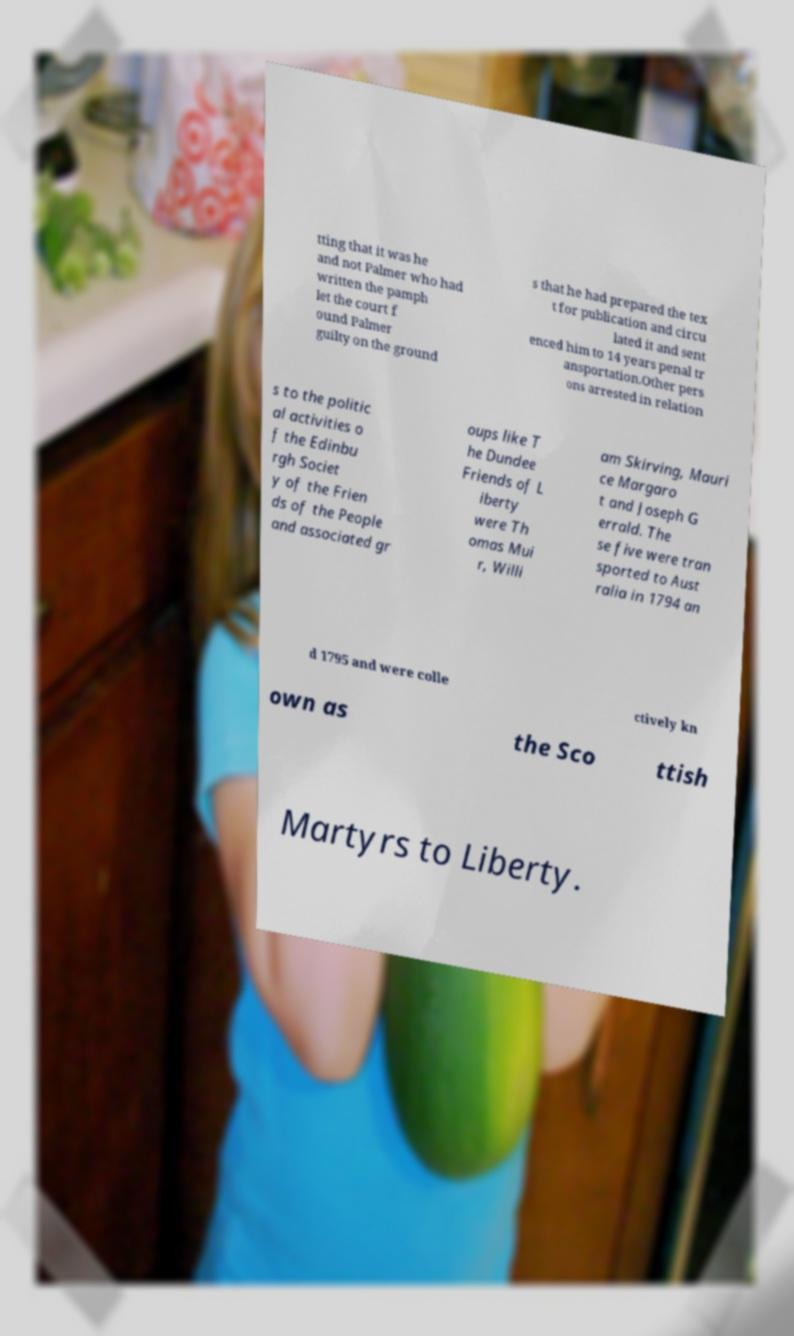For documentation purposes, I need the text within this image transcribed. Could you provide that? tting that it was he and not Palmer who had written the pamph let the court f ound Palmer guilty on the ground s that he had prepared the tex t for publication and circu lated it and sent enced him to 14 years penal tr ansportation.Other pers ons arrested in relation s to the politic al activities o f the Edinbu rgh Societ y of the Frien ds of the People and associated gr oups like T he Dundee Friends of L iberty were Th omas Mui r, Willi am Skirving, Mauri ce Margaro t and Joseph G errald. The se five were tran sported to Aust ralia in 1794 an d 1795 and were colle ctively kn own as the Sco ttish Martyrs to Liberty. 